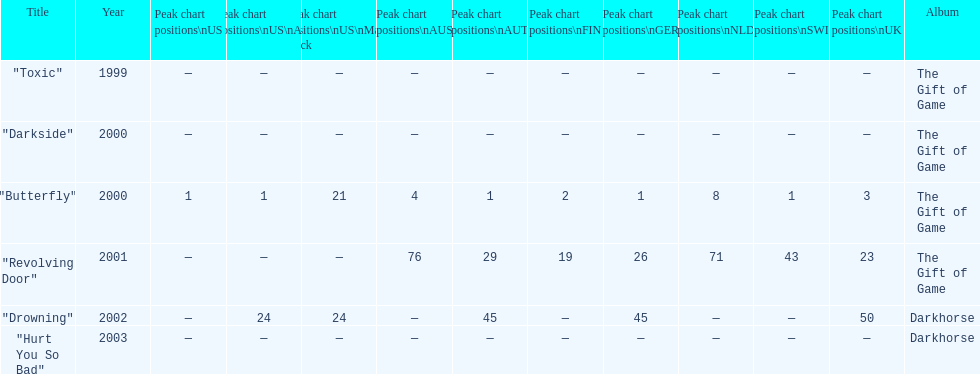When did "drowning" peak at 24 in the us alternate group? 2002. 